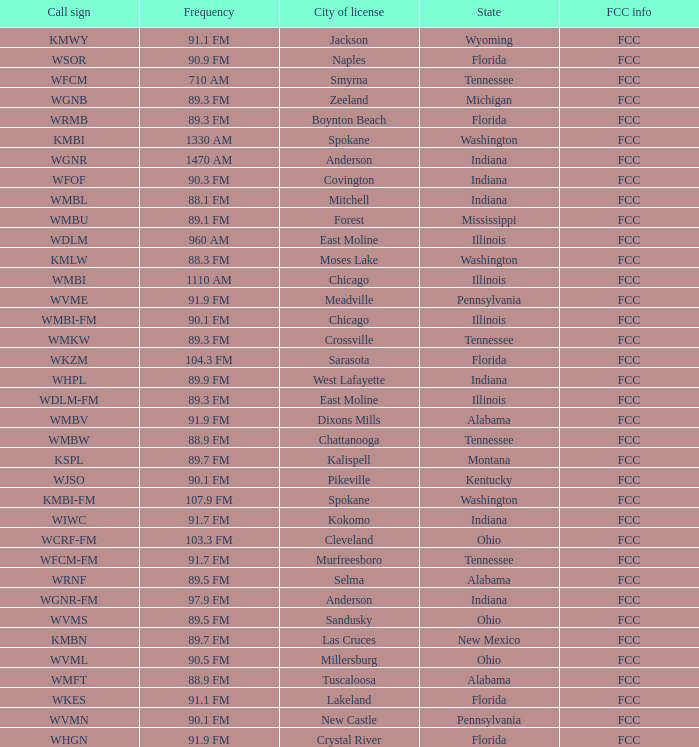What is the frequency of the radio station with a call sign of WGNR-FM? 97.9 FM. 